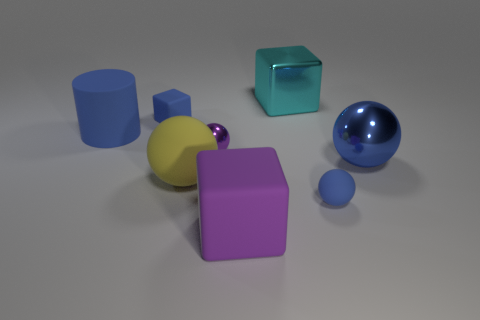Are there any large blue objects left of the big yellow matte sphere?
Provide a short and direct response. Yes. What number of things are either objects that are on the right side of the small metal object or big blue objects?
Your answer should be very brief. 5. What number of big purple rubber things are behind the rubber block that is in front of the blue metallic ball?
Make the answer very short. 0. Is the number of small blue objects that are behind the cyan shiny thing less than the number of large blue objects that are right of the purple sphere?
Offer a terse response. Yes. The shiny object left of the large cyan metal thing that is on the left side of the large metallic sphere is what shape?
Your answer should be very brief. Sphere. How many other objects are the same material as the large purple block?
Ensure brevity in your answer.  4. Are there more large purple matte objects than large matte things?
Make the answer very short. No. There is a matte ball that is left of the large shiny thing that is behind the shiny thing to the right of the small blue rubber sphere; how big is it?
Your response must be concise. Large. There is a yellow object; does it have the same size as the matte cylinder that is in front of the big cyan shiny block?
Offer a terse response. Yes. Is the number of big blue things that are behind the big blue rubber thing less than the number of large matte blocks?
Your answer should be very brief. Yes. 